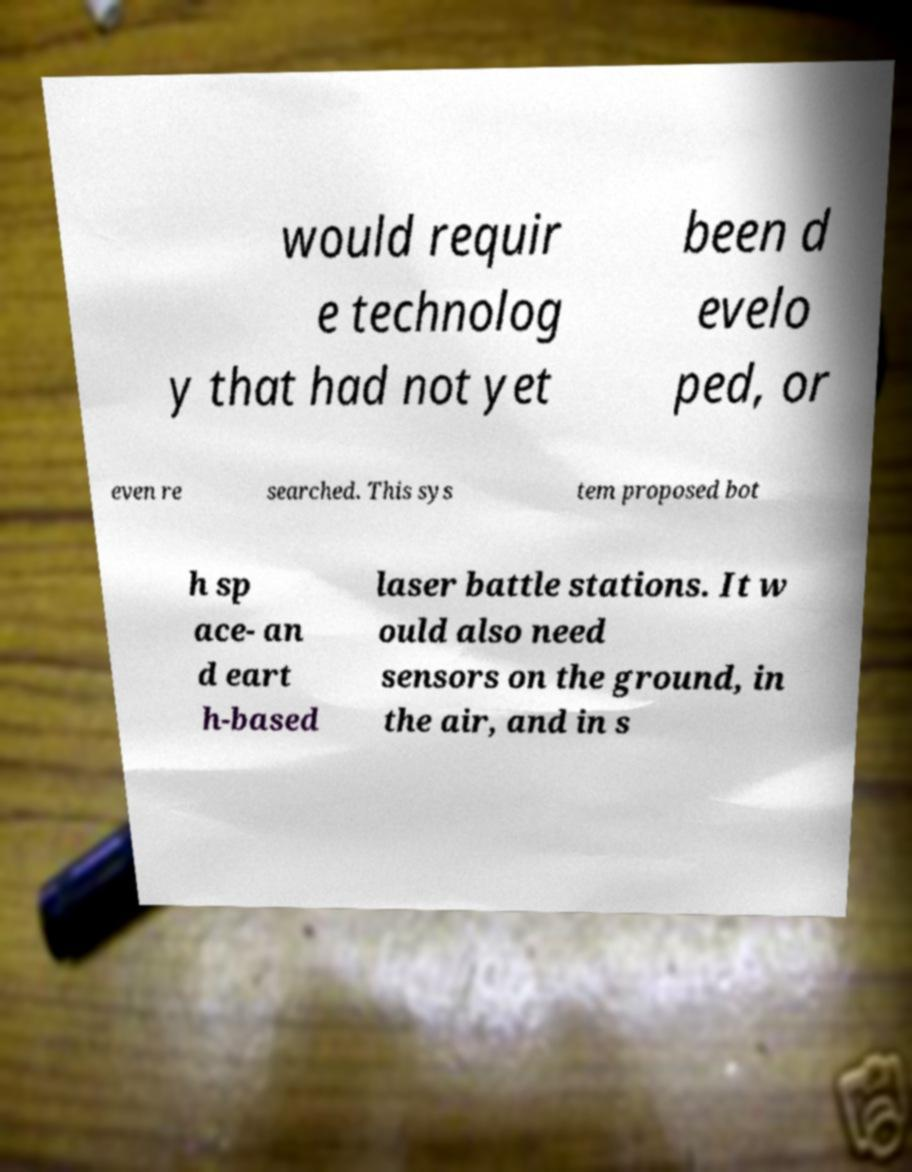What messages or text are displayed in this image? I need them in a readable, typed format. would requir e technolog y that had not yet been d evelo ped, or even re searched. This sys tem proposed bot h sp ace- an d eart h-based laser battle stations. It w ould also need sensors on the ground, in the air, and in s 